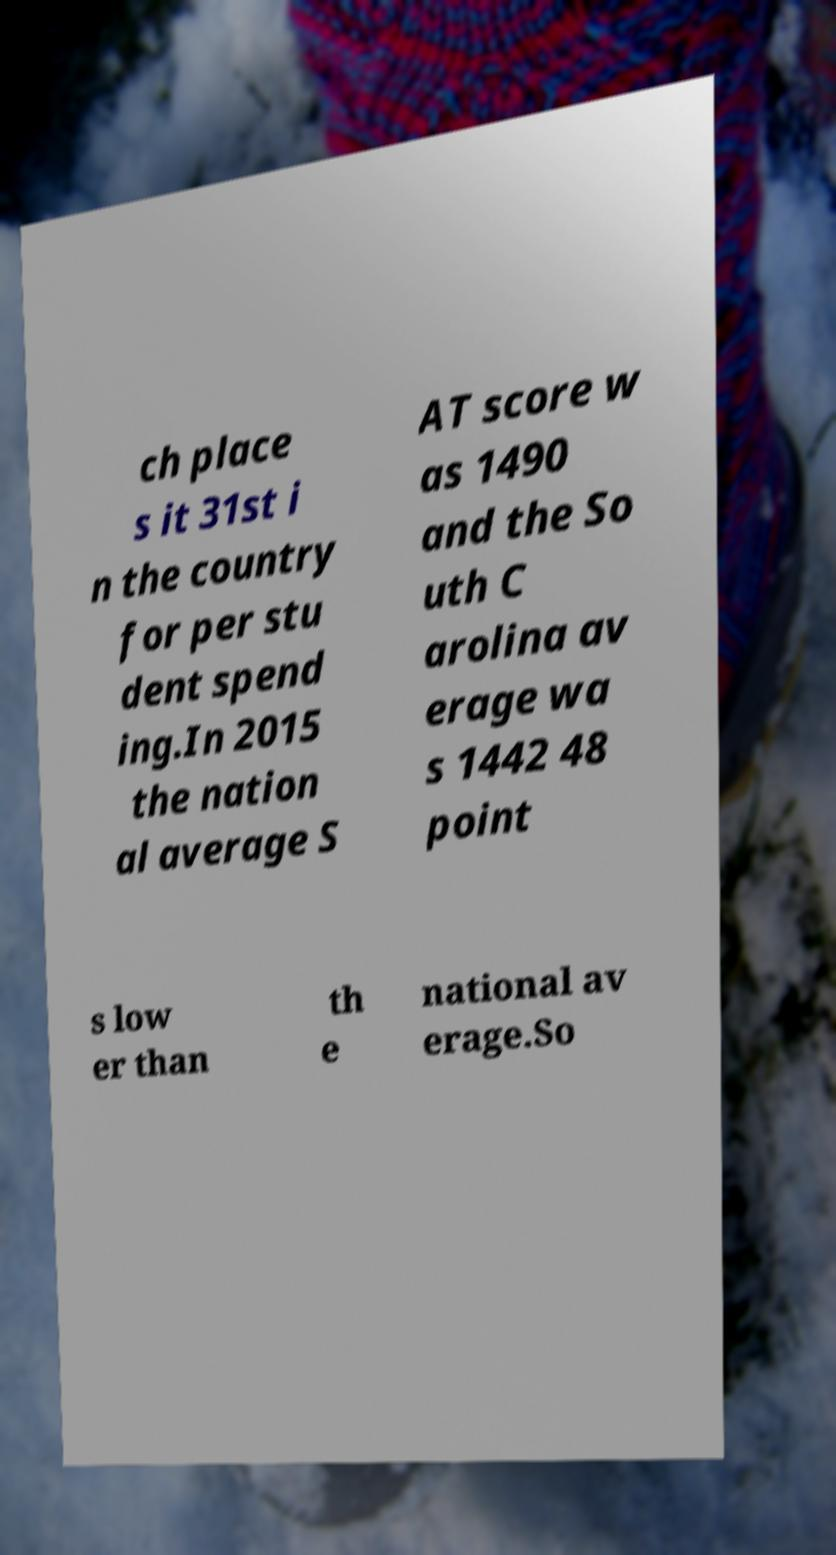Can you read and provide the text displayed in the image?This photo seems to have some interesting text. Can you extract and type it out for me? ch place s it 31st i n the country for per stu dent spend ing.In 2015 the nation al average S AT score w as 1490 and the So uth C arolina av erage wa s 1442 48 point s low er than th e national av erage.So 